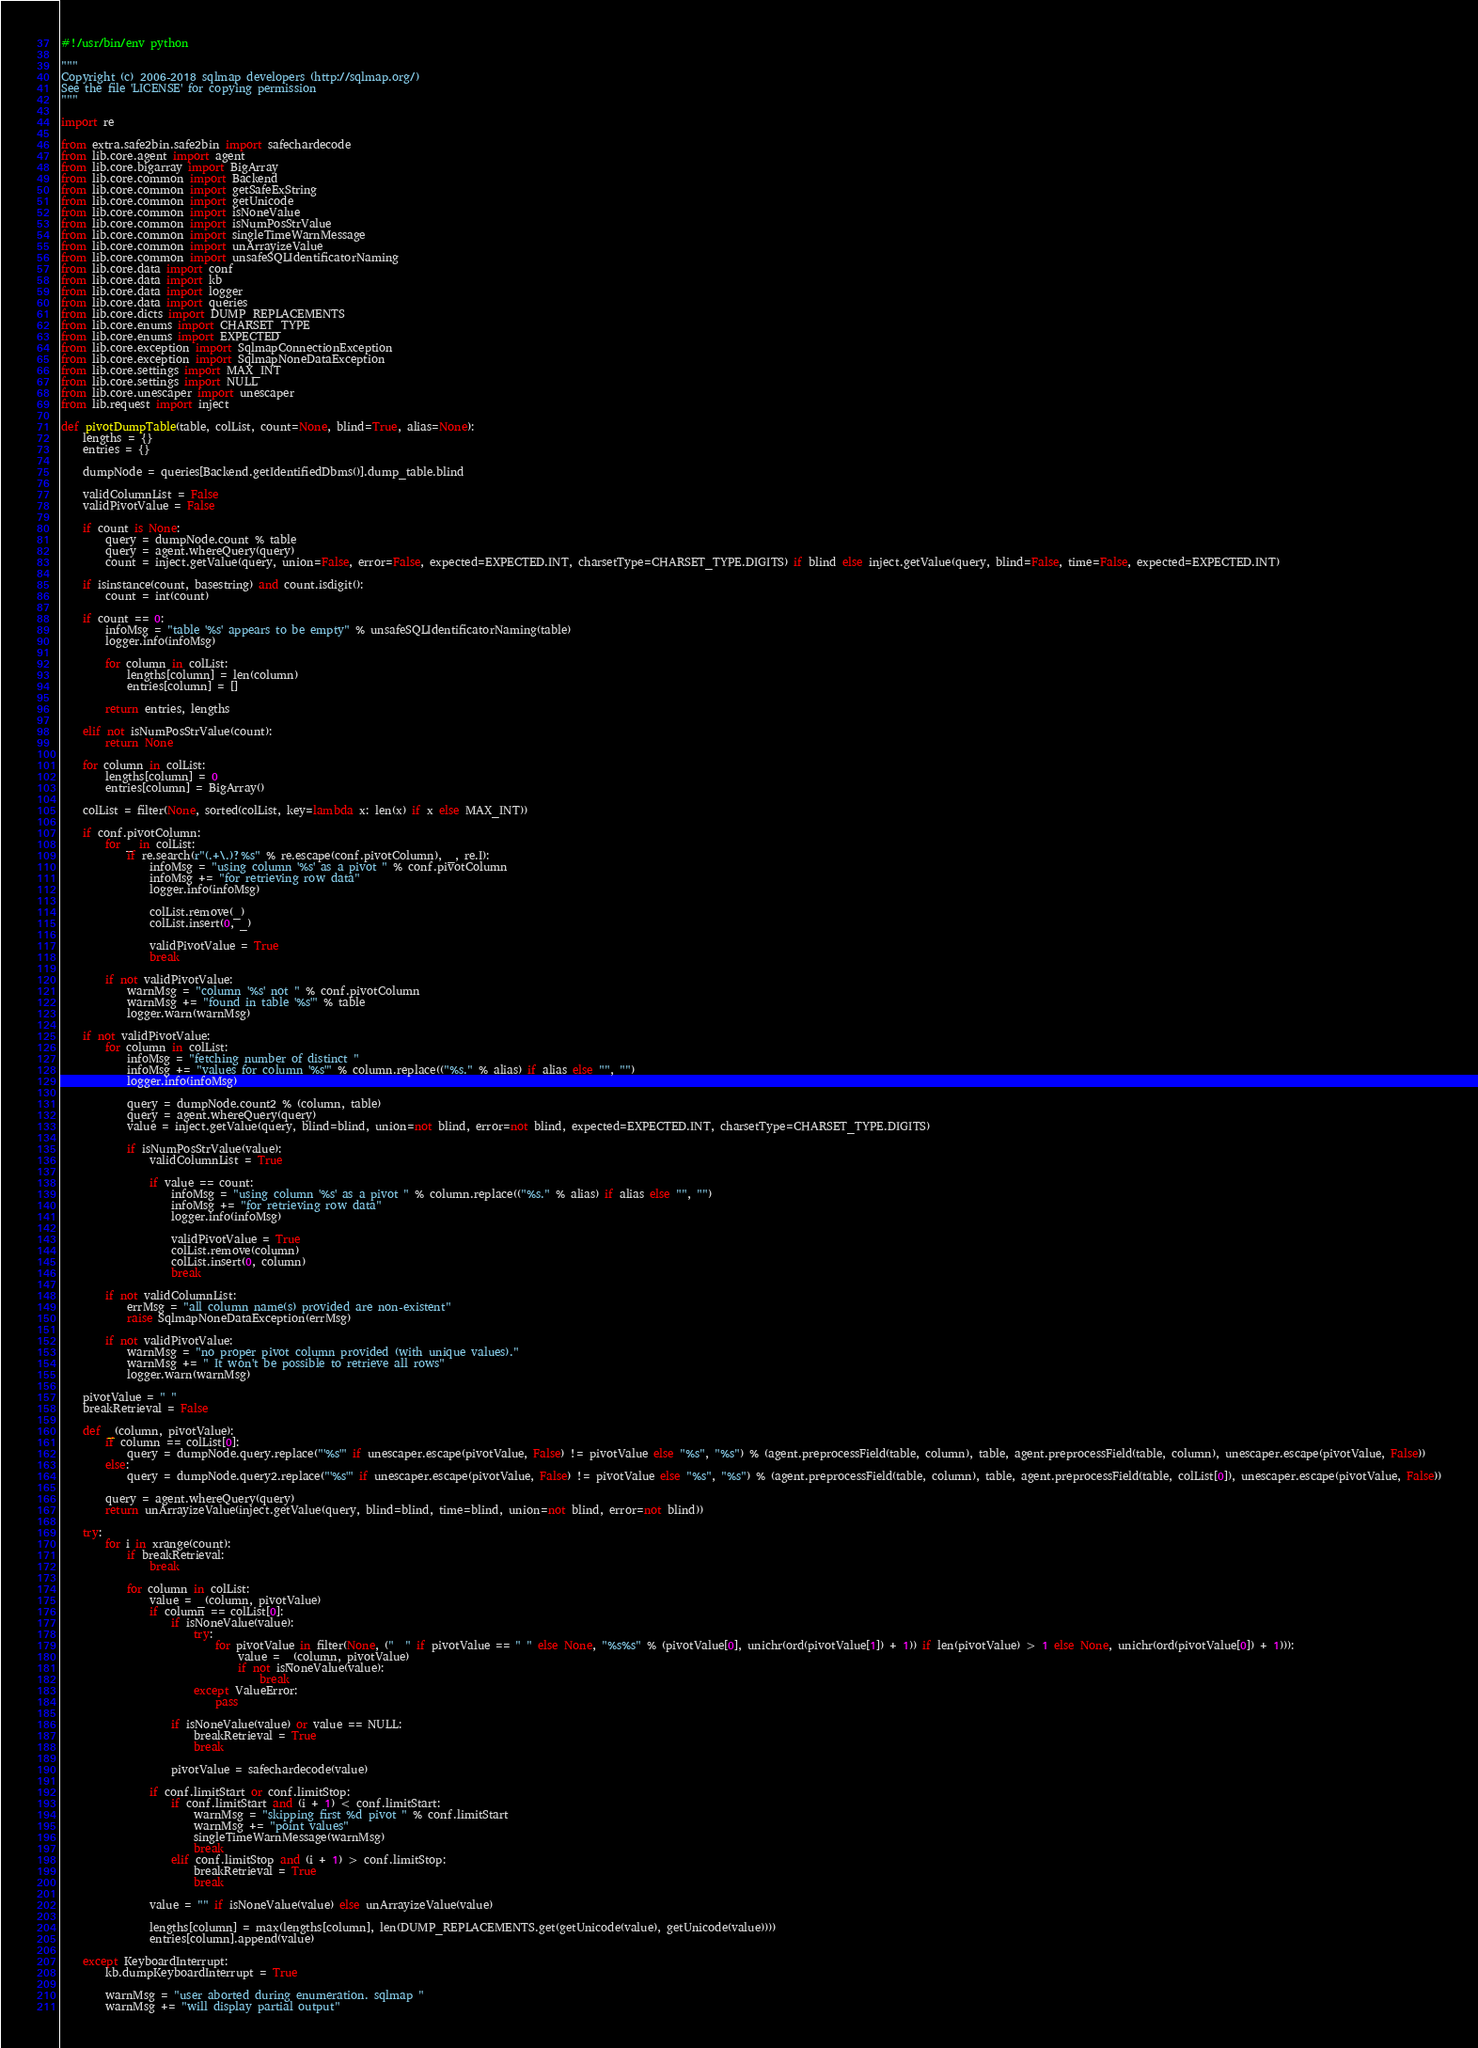<code> <loc_0><loc_0><loc_500><loc_500><_Python_>#!/usr/bin/env python

"""
Copyright (c) 2006-2018 sqlmap developers (http://sqlmap.org/)
See the file 'LICENSE' for copying permission
"""

import re

from extra.safe2bin.safe2bin import safechardecode
from lib.core.agent import agent
from lib.core.bigarray import BigArray
from lib.core.common import Backend
from lib.core.common import getSafeExString
from lib.core.common import getUnicode
from lib.core.common import isNoneValue
from lib.core.common import isNumPosStrValue
from lib.core.common import singleTimeWarnMessage
from lib.core.common import unArrayizeValue
from lib.core.common import unsafeSQLIdentificatorNaming
from lib.core.data import conf
from lib.core.data import kb
from lib.core.data import logger
from lib.core.data import queries
from lib.core.dicts import DUMP_REPLACEMENTS
from lib.core.enums import CHARSET_TYPE
from lib.core.enums import EXPECTED
from lib.core.exception import SqlmapConnectionException
from lib.core.exception import SqlmapNoneDataException
from lib.core.settings import MAX_INT
from lib.core.settings import NULL
from lib.core.unescaper import unescaper
from lib.request import inject

def pivotDumpTable(table, colList, count=None, blind=True, alias=None):
    lengths = {}
    entries = {}

    dumpNode = queries[Backend.getIdentifiedDbms()].dump_table.blind

    validColumnList = False
    validPivotValue = False

    if count is None:
        query = dumpNode.count % table
        query = agent.whereQuery(query)
        count = inject.getValue(query, union=False, error=False, expected=EXPECTED.INT, charsetType=CHARSET_TYPE.DIGITS) if blind else inject.getValue(query, blind=False, time=False, expected=EXPECTED.INT)

    if isinstance(count, basestring) and count.isdigit():
        count = int(count)

    if count == 0:
        infoMsg = "table '%s' appears to be empty" % unsafeSQLIdentificatorNaming(table)
        logger.info(infoMsg)

        for column in colList:
            lengths[column] = len(column)
            entries[column] = []

        return entries, lengths

    elif not isNumPosStrValue(count):
        return None

    for column in colList:
        lengths[column] = 0
        entries[column] = BigArray()

    colList = filter(None, sorted(colList, key=lambda x: len(x) if x else MAX_INT))

    if conf.pivotColumn:
        for _ in colList:
            if re.search(r"(.+\.)?%s" % re.escape(conf.pivotColumn), _, re.I):
                infoMsg = "using column '%s' as a pivot " % conf.pivotColumn
                infoMsg += "for retrieving row data"
                logger.info(infoMsg)

                colList.remove(_)
                colList.insert(0, _)

                validPivotValue = True
                break

        if not validPivotValue:
            warnMsg = "column '%s' not " % conf.pivotColumn
            warnMsg += "found in table '%s'" % table
            logger.warn(warnMsg)

    if not validPivotValue:
        for column in colList:
            infoMsg = "fetching number of distinct "
            infoMsg += "values for column '%s'" % column.replace(("%s." % alias) if alias else "", "")
            logger.info(infoMsg)

            query = dumpNode.count2 % (column, table)
            query = agent.whereQuery(query)
            value = inject.getValue(query, blind=blind, union=not blind, error=not blind, expected=EXPECTED.INT, charsetType=CHARSET_TYPE.DIGITS)

            if isNumPosStrValue(value):
                validColumnList = True

                if value == count:
                    infoMsg = "using column '%s' as a pivot " % column.replace(("%s." % alias) if alias else "", "")
                    infoMsg += "for retrieving row data"
                    logger.info(infoMsg)

                    validPivotValue = True
                    colList.remove(column)
                    colList.insert(0, column)
                    break

        if not validColumnList:
            errMsg = "all column name(s) provided are non-existent"
            raise SqlmapNoneDataException(errMsg)

        if not validPivotValue:
            warnMsg = "no proper pivot column provided (with unique values)."
            warnMsg += " It won't be possible to retrieve all rows"
            logger.warn(warnMsg)

    pivotValue = " "
    breakRetrieval = False

    def _(column, pivotValue):
        if column == colList[0]:
            query = dumpNode.query.replace("'%s'" if unescaper.escape(pivotValue, False) != pivotValue else "%s", "%s") % (agent.preprocessField(table, column), table, agent.preprocessField(table, column), unescaper.escape(pivotValue, False))
        else:
            query = dumpNode.query2.replace("'%s'" if unescaper.escape(pivotValue, False) != pivotValue else "%s", "%s") % (agent.preprocessField(table, column), table, agent.preprocessField(table, colList[0]), unescaper.escape(pivotValue, False))

        query = agent.whereQuery(query)
        return unArrayizeValue(inject.getValue(query, blind=blind, time=blind, union=not blind, error=not blind))

    try:
        for i in xrange(count):
            if breakRetrieval:
                break

            for column in colList:
                value = _(column, pivotValue)
                if column == colList[0]:
                    if isNoneValue(value):
                        try:
                            for pivotValue in filter(None, ("  " if pivotValue == " " else None, "%s%s" % (pivotValue[0], unichr(ord(pivotValue[1]) + 1)) if len(pivotValue) > 1 else None, unichr(ord(pivotValue[0]) + 1))):
                                value = _(column, pivotValue)
                                if not isNoneValue(value):
                                    break
                        except ValueError:
                            pass

                    if isNoneValue(value) or value == NULL:
                        breakRetrieval = True
                        break

                    pivotValue = safechardecode(value)

                if conf.limitStart or conf.limitStop:
                    if conf.limitStart and (i + 1) < conf.limitStart:
                        warnMsg = "skipping first %d pivot " % conf.limitStart
                        warnMsg += "point values"
                        singleTimeWarnMessage(warnMsg)
                        break
                    elif conf.limitStop and (i + 1) > conf.limitStop:
                        breakRetrieval = True
                        break

                value = "" if isNoneValue(value) else unArrayizeValue(value)

                lengths[column] = max(lengths[column], len(DUMP_REPLACEMENTS.get(getUnicode(value), getUnicode(value))))
                entries[column].append(value)

    except KeyboardInterrupt:
        kb.dumpKeyboardInterrupt = True

        warnMsg = "user aborted during enumeration. sqlmap "
        warnMsg += "will display partial output"</code> 